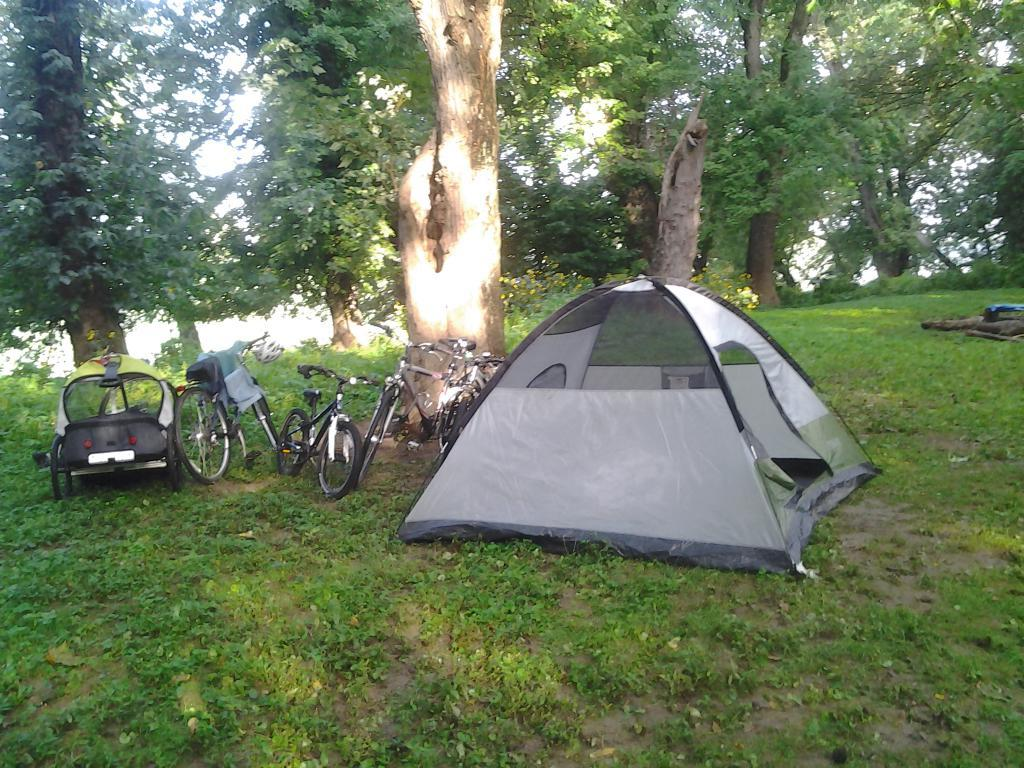What type of shelter is visible in the image? There is a tent in the image. What mode of transportation can be seen in the image? There are bicycles in the image. Where is the image set? The image is set in a forest. What type of vegetation is present in the image? Trees are present in the image. What type of lumber is being used to construct the tent in the image? There is no mention of lumber or the construction of the tent in the image. Can you see any animals from the zoo in the image? There is no zoo or animals from a zoo present in the image. 